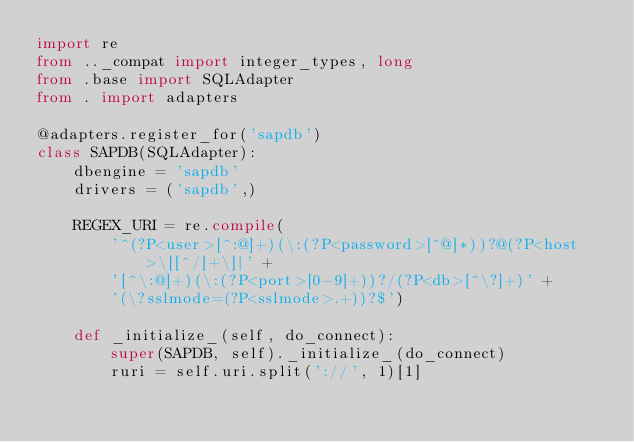<code> <loc_0><loc_0><loc_500><loc_500><_Python_>import re
from .._compat import integer_types, long
from .base import SQLAdapter
from . import adapters

@adapters.register_for('sapdb')
class SAPDB(SQLAdapter):
    dbengine = 'sapdb'
    drivers = ('sapdb',)

    REGEX_URI = re.compile(
        '^(?P<user>[^:@]+)(\:(?P<password>[^@]*))?@(?P<host>\[[^/]+\]|' +
        '[^\:@]+)(\:(?P<port>[0-9]+))?/(?P<db>[^\?]+)' +
        '(\?sslmode=(?P<sslmode>.+))?$')

    def _initialize_(self, do_connect):
        super(SAPDB, self)._initialize_(do_connect)
        ruri = self.uri.split('://', 1)[1]</code> 